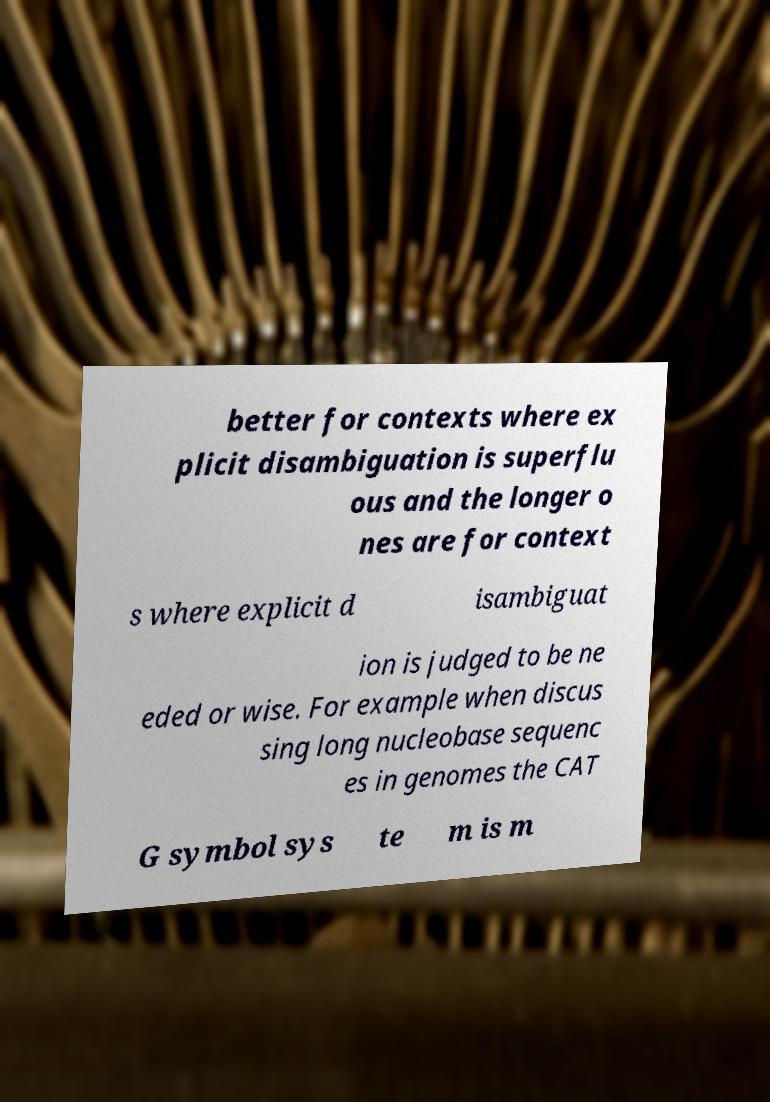There's text embedded in this image that I need extracted. Can you transcribe it verbatim? better for contexts where ex plicit disambiguation is superflu ous and the longer o nes are for context s where explicit d isambiguat ion is judged to be ne eded or wise. For example when discus sing long nucleobase sequenc es in genomes the CAT G symbol sys te m is m 